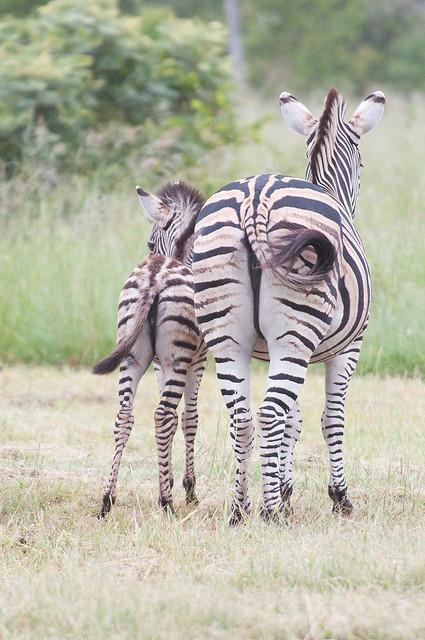How many zebras are there?
Give a very brief answer. 2. How many zebras are in the picture?
Give a very brief answer. 2. 